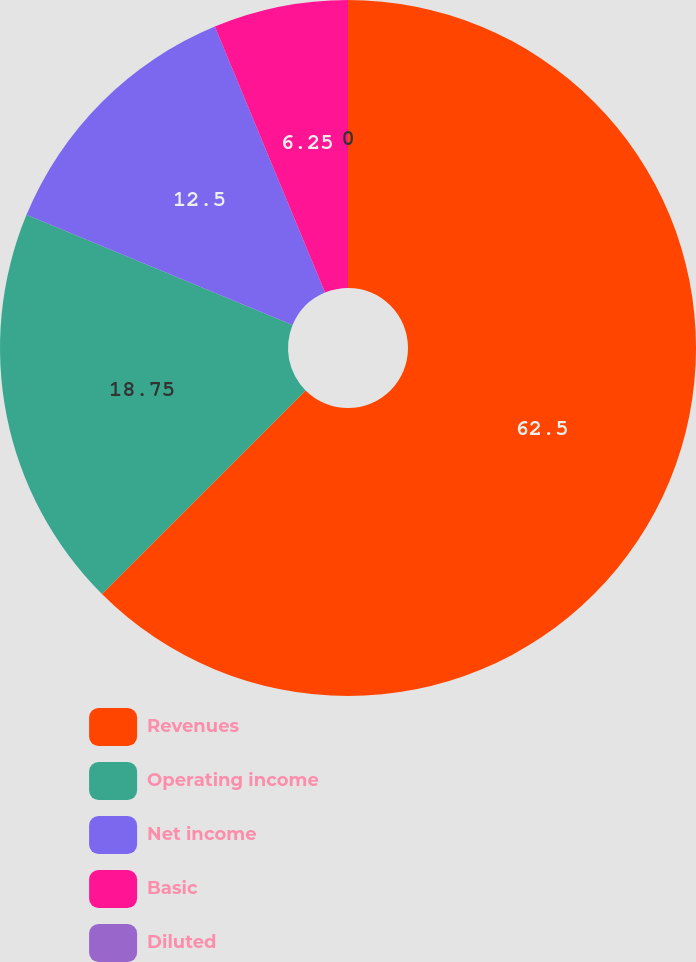<chart> <loc_0><loc_0><loc_500><loc_500><pie_chart><fcel>Revenues<fcel>Operating income<fcel>Net income<fcel>Basic<fcel>Diluted<nl><fcel>62.5%<fcel>18.75%<fcel>12.5%<fcel>6.25%<fcel>0.0%<nl></chart> 